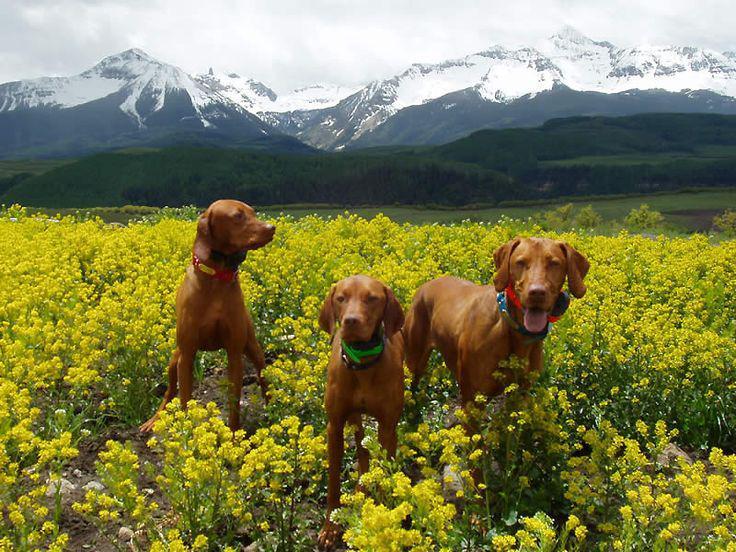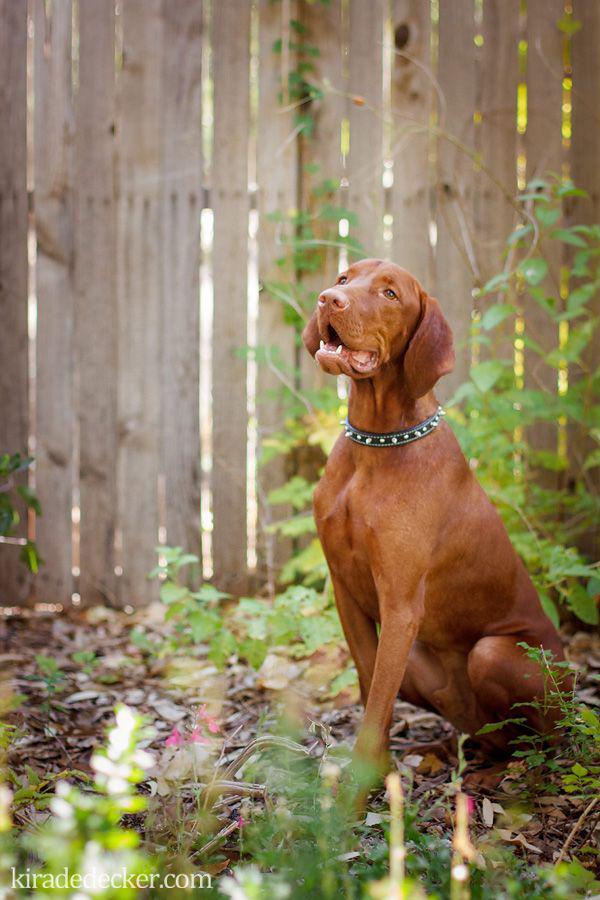The first image is the image on the left, the second image is the image on the right. For the images shown, is this caption "In one image, a tan dog is standing upright with its front feet on a raised area before it, the back of its head visible as it looks away." true? Answer yes or no. No. The first image is the image on the left, the second image is the image on the right. Considering the images on both sides, is "The left image shows a dog with its front paws propped up, gazing toward a scenic view away from the camera, and the right image features purple flowers behind one dog." valid? Answer yes or no. No. 